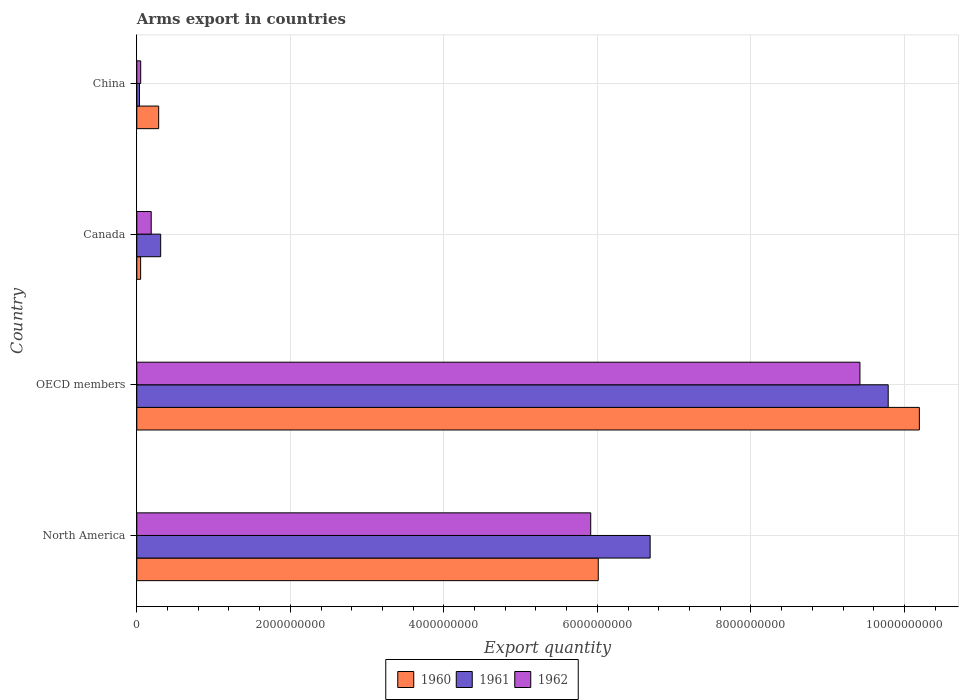Are the number of bars on each tick of the Y-axis equal?
Give a very brief answer. Yes. How many bars are there on the 4th tick from the top?
Your response must be concise. 3. How many bars are there on the 2nd tick from the bottom?
Your answer should be very brief. 3. What is the label of the 3rd group of bars from the top?
Your answer should be compact. OECD members. What is the total arms export in 1961 in Canada?
Make the answer very short. 3.11e+08. Across all countries, what is the maximum total arms export in 1962?
Keep it short and to the point. 9.42e+09. Across all countries, what is the minimum total arms export in 1960?
Keep it short and to the point. 5.00e+07. In which country was the total arms export in 1961 maximum?
Offer a terse response. OECD members. In which country was the total arms export in 1960 minimum?
Provide a short and direct response. Canada. What is the total total arms export in 1962 in the graph?
Provide a short and direct response. 1.56e+1. What is the difference between the total arms export in 1962 in Canada and that in China?
Keep it short and to the point. 1.37e+08. What is the difference between the total arms export in 1961 in North America and the total arms export in 1962 in Canada?
Keep it short and to the point. 6.50e+09. What is the average total arms export in 1960 per country?
Make the answer very short. 4.14e+09. What is the difference between the total arms export in 1961 and total arms export in 1962 in North America?
Your response must be concise. 7.74e+08. What is the ratio of the total arms export in 1962 in Canada to that in China?
Keep it short and to the point. 3.69. What is the difference between the highest and the second highest total arms export in 1961?
Ensure brevity in your answer.  3.10e+09. What is the difference between the highest and the lowest total arms export in 1961?
Your answer should be very brief. 9.75e+09. In how many countries, is the total arms export in 1961 greater than the average total arms export in 1961 taken over all countries?
Provide a short and direct response. 2. What does the 1st bar from the top in China represents?
Ensure brevity in your answer.  1962. What does the 1st bar from the bottom in China represents?
Your answer should be very brief. 1960. Is it the case that in every country, the sum of the total arms export in 1962 and total arms export in 1960 is greater than the total arms export in 1961?
Your answer should be very brief. No. How many bars are there?
Offer a very short reply. 12. Are all the bars in the graph horizontal?
Offer a terse response. Yes. What is the difference between two consecutive major ticks on the X-axis?
Offer a very short reply. 2.00e+09. Does the graph contain any zero values?
Ensure brevity in your answer.  No. Does the graph contain grids?
Your answer should be very brief. Yes. How are the legend labels stacked?
Offer a very short reply. Horizontal. What is the title of the graph?
Your answer should be very brief. Arms export in countries. Does "2002" appear as one of the legend labels in the graph?
Make the answer very short. No. What is the label or title of the X-axis?
Make the answer very short. Export quantity. What is the label or title of the Y-axis?
Ensure brevity in your answer.  Country. What is the Export quantity in 1960 in North America?
Your answer should be very brief. 6.01e+09. What is the Export quantity of 1961 in North America?
Offer a very short reply. 6.69e+09. What is the Export quantity of 1962 in North America?
Your answer should be compact. 5.91e+09. What is the Export quantity of 1960 in OECD members?
Your answer should be compact. 1.02e+1. What is the Export quantity of 1961 in OECD members?
Make the answer very short. 9.79e+09. What is the Export quantity in 1962 in OECD members?
Offer a very short reply. 9.42e+09. What is the Export quantity in 1961 in Canada?
Your answer should be compact. 3.11e+08. What is the Export quantity of 1962 in Canada?
Provide a succinct answer. 1.88e+08. What is the Export quantity in 1960 in China?
Your answer should be very brief. 2.85e+08. What is the Export quantity in 1961 in China?
Offer a terse response. 3.50e+07. What is the Export quantity in 1962 in China?
Provide a succinct answer. 5.10e+07. Across all countries, what is the maximum Export quantity in 1960?
Ensure brevity in your answer.  1.02e+1. Across all countries, what is the maximum Export quantity in 1961?
Offer a terse response. 9.79e+09. Across all countries, what is the maximum Export quantity in 1962?
Your answer should be very brief. 9.42e+09. Across all countries, what is the minimum Export quantity of 1961?
Provide a succinct answer. 3.50e+07. Across all countries, what is the minimum Export quantity in 1962?
Offer a very short reply. 5.10e+07. What is the total Export quantity of 1960 in the graph?
Make the answer very short. 1.65e+1. What is the total Export quantity in 1961 in the graph?
Ensure brevity in your answer.  1.68e+1. What is the total Export quantity of 1962 in the graph?
Your response must be concise. 1.56e+1. What is the difference between the Export quantity of 1960 in North America and that in OECD members?
Ensure brevity in your answer.  -4.18e+09. What is the difference between the Export quantity of 1961 in North America and that in OECD members?
Your response must be concise. -3.10e+09. What is the difference between the Export quantity in 1962 in North America and that in OECD members?
Ensure brevity in your answer.  -3.51e+09. What is the difference between the Export quantity of 1960 in North America and that in Canada?
Make the answer very short. 5.96e+09. What is the difference between the Export quantity of 1961 in North America and that in Canada?
Give a very brief answer. 6.38e+09. What is the difference between the Export quantity of 1962 in North America and that in Canada?
Keep it short and to the point. 5.72e+09. What is the difference between the Export quantity of 1960 in North America and that in China?
Ensure brevity in your answer.  5.73e+09. What is the difference between the Export quantity of 1961 in North America and that in China?
Ensure brevity in your answer.  6.65e+09. What is the difference between the Export quantity in 1962 in North America and that in China?
Offer a terse response. 5.86e+09. What is the difference between the Export quantity of 1960 in OECD members and that in Canada?
Your response must be concise. 1.01e+1. What is the difference between the Export quantity in 1961 in OECD members and that in Canada?
Give a very brief answer. 9.48e+09. What is the difference between the Export quantity of 1962 in OECD members and that in Canada?
Offer a very short reply. 9.23e+09. What is the difference between the Export quantity in 1960 in OECD members and that in China?
Your answer should be compact. 9.91e+09. What is the difference between the Export quantity of 1961 in OECD members and that in China?
Make the answer very short. 9.75e+09. What is the difference between the Export quantity in 1962 in OECD members and that in China?
Your answer should be very brief. 9.37e+09. What is the difference between the Export quantity in 1960 in Canada and that in China?
Make the answer very short. -2.35e+08. What is the difference between the Export quantity of 1961 in Canada and that in China?
Give a very brief answer. 2.76e+08. What is the difference between the Export quantity of 1962 in Canada and that in China?
Offer a very short reply. 1.37e+08. What is the difference between the Export quantity of 1960 in North America and the Export quantity of 1961 in OECD members?
Ensure brevity in your answer.  -3.78e+09. What is the difference between the Export quantity of 1960 in North America and the Export quantity of 1962 in OECD members?
Your response must be concise. -3.41e+09. What is the difference between the Export quantity in 1961 in North America and the Export quantity in 1962 in OECD members?
Ensure brevity in your answer.  -2.73e+09. What is the difference between the Export quantity of 1960 in North America and the Export quantity of 1961 in Canada?
Your answer should be compact. 5.70e+09. What is the difference between the Export quantity in 1960 in North America and the Export quantity in 1962 in Canada?
Ensure brevity in your answer.  5.82e+09. What is the difference between the Export quantity of 1961 in North America and the Export quantity of 1962 in Canada?
Keep it short and to the point. 6.50e+09. What is the difference between the Export quantity in 1960 in North America and the Export quantity in 1961 in China?
Make the answer very short. 5.98e+09. What is the difference between the Export quantity of 1960 in North America and the Export quantity of 1962 in China?
Your answer should be very brief. 5.96e+09. What is the difference between the Export quantity of 1961 in North America and the Export quantity of 1962 in China?
Your answer should be compact. 6.64e+09. What is the difference between the Export quantity of 1960 in OECD members and the Export quantity of 1961 in Canada?
Provide a short and direct response. 9.88e+09. What is the difference between the Export quantity in 1960 in OECD members and the Export quantity in 1962 in Canada?
Make the answer very short. 1.00e+1. What is the difference between the Export quantity in 1961 in OECD members and the Export quantity in 1962 in Canada?
Your answer should be very brief. 9.60e+09. What is the difference between the Export quantity of 1960 in OECD members and the Export quantity of 1961 in China?
Give a very brief answer. 1.02e+1. What is the difference between the Export quantity of 1960 in OECD members and the Export quantity of 1962 in China?
Keep it short and to the point. 1.01e+1. What is the difference between the Export quantity of 1961 in OECD members and the Export quantity of 1962 in China?
Offer a terse response. 9.74e+09. What is the difference between the Export quantity in 1960 in Canada and the Export quantity in 1961 in China?
Make the answer very short. 1.50e+07. What is the difference between the Export quantity of 1961 in Canada and the Export quantity of 1962 in China?
Provide a succinct answer. 2.60e+08. What is the average Export quantity in 1960 per country?
Make the answer very short. 4.14e+09. What is the average Export quantity in 1961 per country?
Keep it short and to the point. 4.21e+09. What is the average Export quantity in 1962 per country?
Ensure brevity in your answer.  3.89e+09. What is the difference between the Export quantity in 1960 and Export quantity in 1961 in North America?
Your response must be concise. -6.76e+08. What is the difference between the Export quantity of 1960 and Export quantity of 1962 in North America?
Provide a succinct answer. 9.80e+07. What is the difference between the Export quantity in 1961 and Export quantity in 1962 in North America?
Offer a very short reply. 7.74e+08. What is the difference between the Export quantity in 1960 and Export quantity in 1961 in OECD members?
Your answer should be very brief. 4.06e+08. What is the difference between the Export quantity in 1960 and Export quantity in 1962 in OECD members?
Your response must be concise. 7.74e+08. What is the difference between the Export quantity of 1961 and Export quantity of 1962 in OECD members?
Provide a succinct answer. 3.68e+08. What is the difference between the Export quantity in 1960 and Export quantity in 1961 in Canada?
Provide a succinct answer. -2.61e+08. What is the difference between the Export quantity in 1960 and Export quantity in 1962 in Canada?
Keep it short and to the point. -1.38e+08. What is the difference between the Export quantity of 1961 and Export quantity of 1962 in Canada?
Make the answer very short. 1.23e+08. What is the difference between the Export quantity of 1960 and Export quantity of 1961 in China?
Provide a short and direct response. 2.50e+08. What is the difference between the Export quantity in 1960 and Export quantity in 1962 in China?
Provide a succinct answer. 2.34e+08. What is the difference between the Export quantity in 1961 and Export quantity in 1962 in China?
Your answer should be very brief. -1.60e+07. What is the ratio of the Export quantity in 1960 in North America to that in OECD members?
Your answer should be very brief. 0.59. What is the ratio of the Export quantity of 1961 in North America to that in OECD members?
Give a very brief answer. 0.68. What is the ratio of the Export quantity in 1962 in North America to that in OECD members?
Offer a terse response. 0.63. What is the ratio of the Export quantity in 1960 in North America to that in Canada?
Make the answer very short. 120.22. What is the ratio of the Export quantity of 1961 in North America to that in Canada?
Ensure brevity in your answer.  21.5. What is the ratio of the Export quantity of 1962 in North America to that in Canada?
Keep it short and to the point. 31.45. What is the ratio of the Export quantity of 1960 in North America to that in China?
Your response must be concise. 21.09. What is the ratio of the Export quantity in 1961 in North America to that in China?
Provide a succinct answer. 191.06. What is the ratio of the Export quantity of 1962 in North America to that in China?
Keep it short and to the point. 115.94. What is the ratio of the Export quantity in 1960 in OECD members to that in Canada?
Provide a succinct answer. 203.88. What is the ratio of the Export quantity of 1961 in OECD members to that in Canada?
Make the answer very short. 31.47. What is the ratio of the Export quantity in 1962 in OECD members to that in Canada?
Provide a short and direct response. 50.11. What is the ratio of the Export quantity of 1960 in OECD members to that in China?
Offer a terse response. 35.77. What is the ratio of the Export quantity in 1961 in OECD members to that in China?
Your response must be concise. 279.66. What is the ratio of the Export quantity of 1962 in OECD members to that in China?
Offer a very short reply. 184.71. What is the ratio of the Export quantity of 1960 in Canada to that in China?
Ensure brevity in your answer.  0.18. What is the ratio of the Export quantity of 1961 in Canada to that in China?
Offer a terse response. 8.89. What is the ratio of the Export quantity in 1962 in Canada to that in China?
Give a very brief answer. 3.69. What is the difference between the highest and the second highest Export quantity in 1960?
Provide a short and direct response. 4.18e+09. What is the difference between the highest and the second highest Export quantity in 1961?
Provide a short and direct response. 3.10e+09. What is the difference between the highest and the second highest Export quantity in 1962?
Provide a short and direct response. 3.51e+09. What is the difference between the highest and the lowest Export quantity of 1960?
Make the answer very short. 1.01e+1. What is the difference between the highest and the lowest Export quantity of 1961?
Your response must be concise. 9.75e+09. What is the difference between the highest and the lowest Export quantity of 1962?
Make the answer very short. 9.37e+09. 